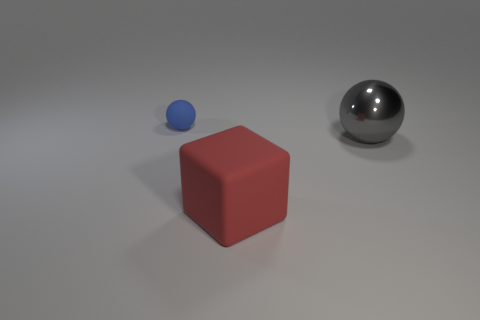Add 3 big red matte objects. How many objects exist? 6 Subtract all balls. How many objects are left? 1 Add 1 small blue rubber spheres. How many small blue rubber spheres are left? 2 Add 2 blue metallic cubes. How many blue metallic cubes exist? 2 Subtract 0 yellow balls. How many objects are left? 3 Subtract all gray metal cylinders. Subtract all small matte things. How many objects are left? 2 